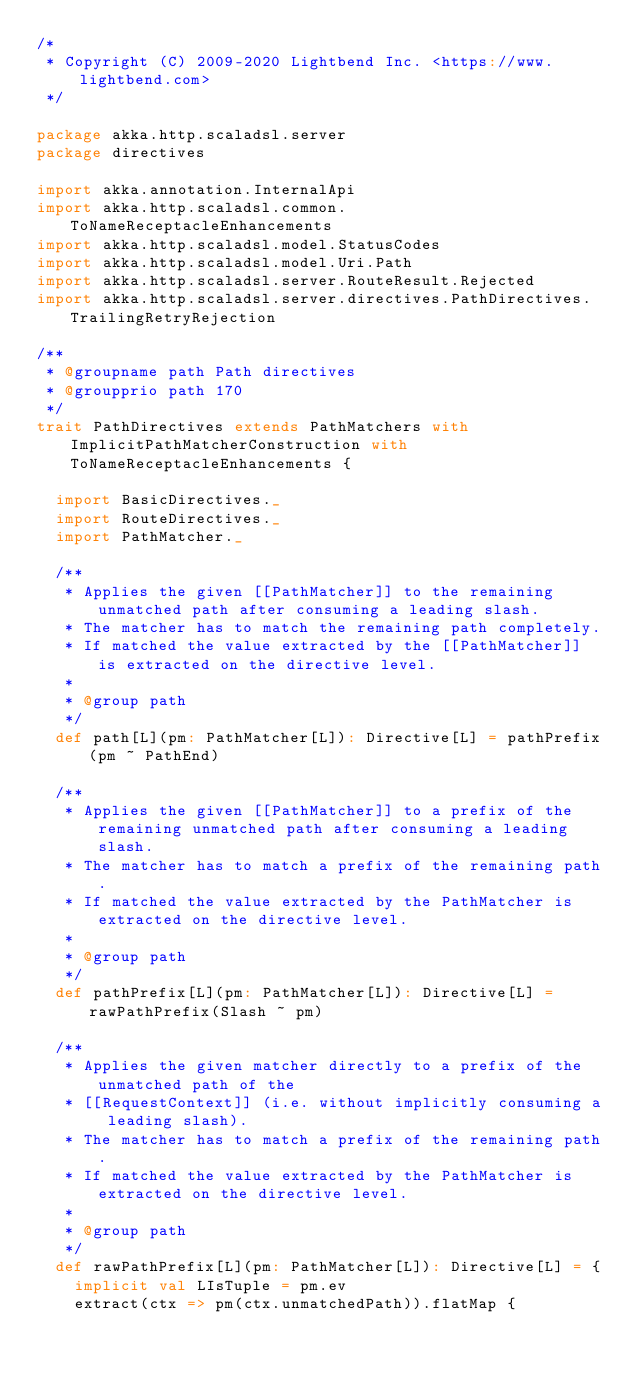Convert code to text. <code><loc_0><loc_0><loc_500><loc_500><_Scala_>/*
 * Copyright (C) 2009-2020 Lightbend Inc. <https://www.lightbend.com>
 */

package akka.http.scaladsl.server
package directives

import akka.annotation.InternalApi
import akka.http.scaladsl.common.ToNameReceptacleEnhancements
import akka.http.scaladsl.model.StatusCodes
import akka.http.scaladsl.model.Uri.Path
import akka.http.scaladsl.server.RouteResult.Rejected
import akka.http.scaladsl.server.directives.PathDirectives.TrailingRetryRejection

/**
 * @groupname path Path directives
 * @groupprio path 170
 */
trait PathDirectives extends PathMatchers with ImplicitPathMatcherConstruction with ToNameReceptacleEnhancements {

  import BasicDirectives._
  import RouteDirectives._
  import PathMatcher._

  /**
   * Applies the given [[PathMatcher]] to the remaining unmatched path after consuming a leading slash.
   * The matcher has to match the remaining path completely.
   * If matched the value extracted by the [[PathMatcher]] is extracted on the directive level.
   *
   * @group path
   */
  def path[L](pm: PathMatcher[L]): Directive[L] = pathPrefix(pm ~ PathEnd)

  /**
   * Applies the given [[PathMatcher]] to a prefix of the remaining unmatched path after consuming a leading slash.
   * The matcher has to match a prefix of the remaining path.
   * If matched the value extracted by the PathMatcher is extracted on the directive level.
   *
   * @group path
   */
  def pathPrefix[L](pm: PathMatcher[L]): Directive[L] = rawPathPrefix(Slash ~ pm)

  /**
   * Applies the given matcher directly to a prefix of the unmatched path of the
   * [[RequestContext]] (i.e. without implicitly consuming a leading slash).
   * The matcher has to match a prefix of the remaining path.
   * If matched the value extracted by the PathMatcher is extracted on the directive level.
   *
   * @group path
   */
  def rawPathPrefix[L](pm: PathMatcher[L]): Directive[L] = {
    implicit val LIsTuple = pm.ev
    extract(ctx => pm(ctx.unmatchedPath)).flatMap {</code> 